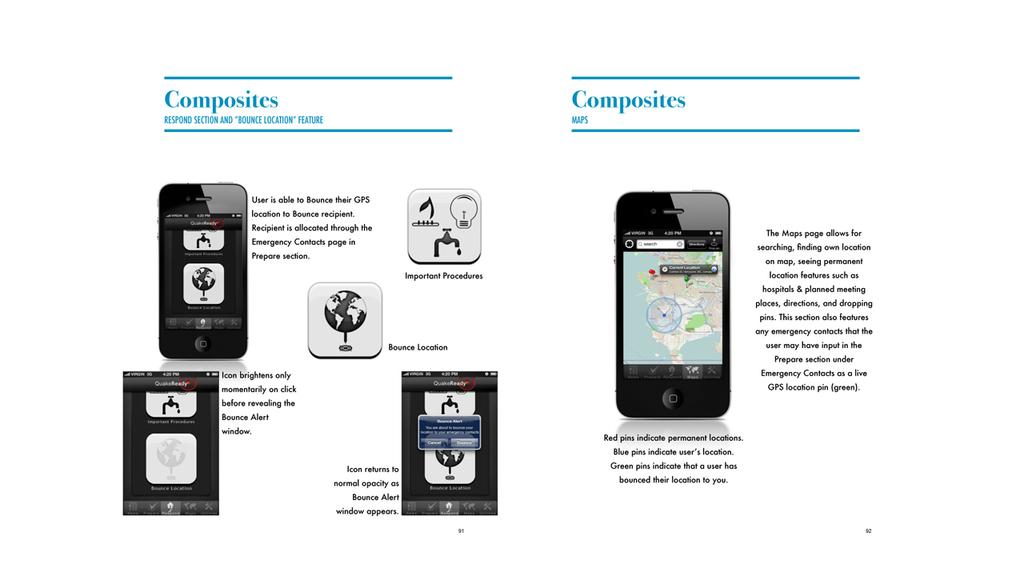<image>
Render a clear and concise summary of the photo. Composites for a cell phone focus on various features such as GPS and brightness. 